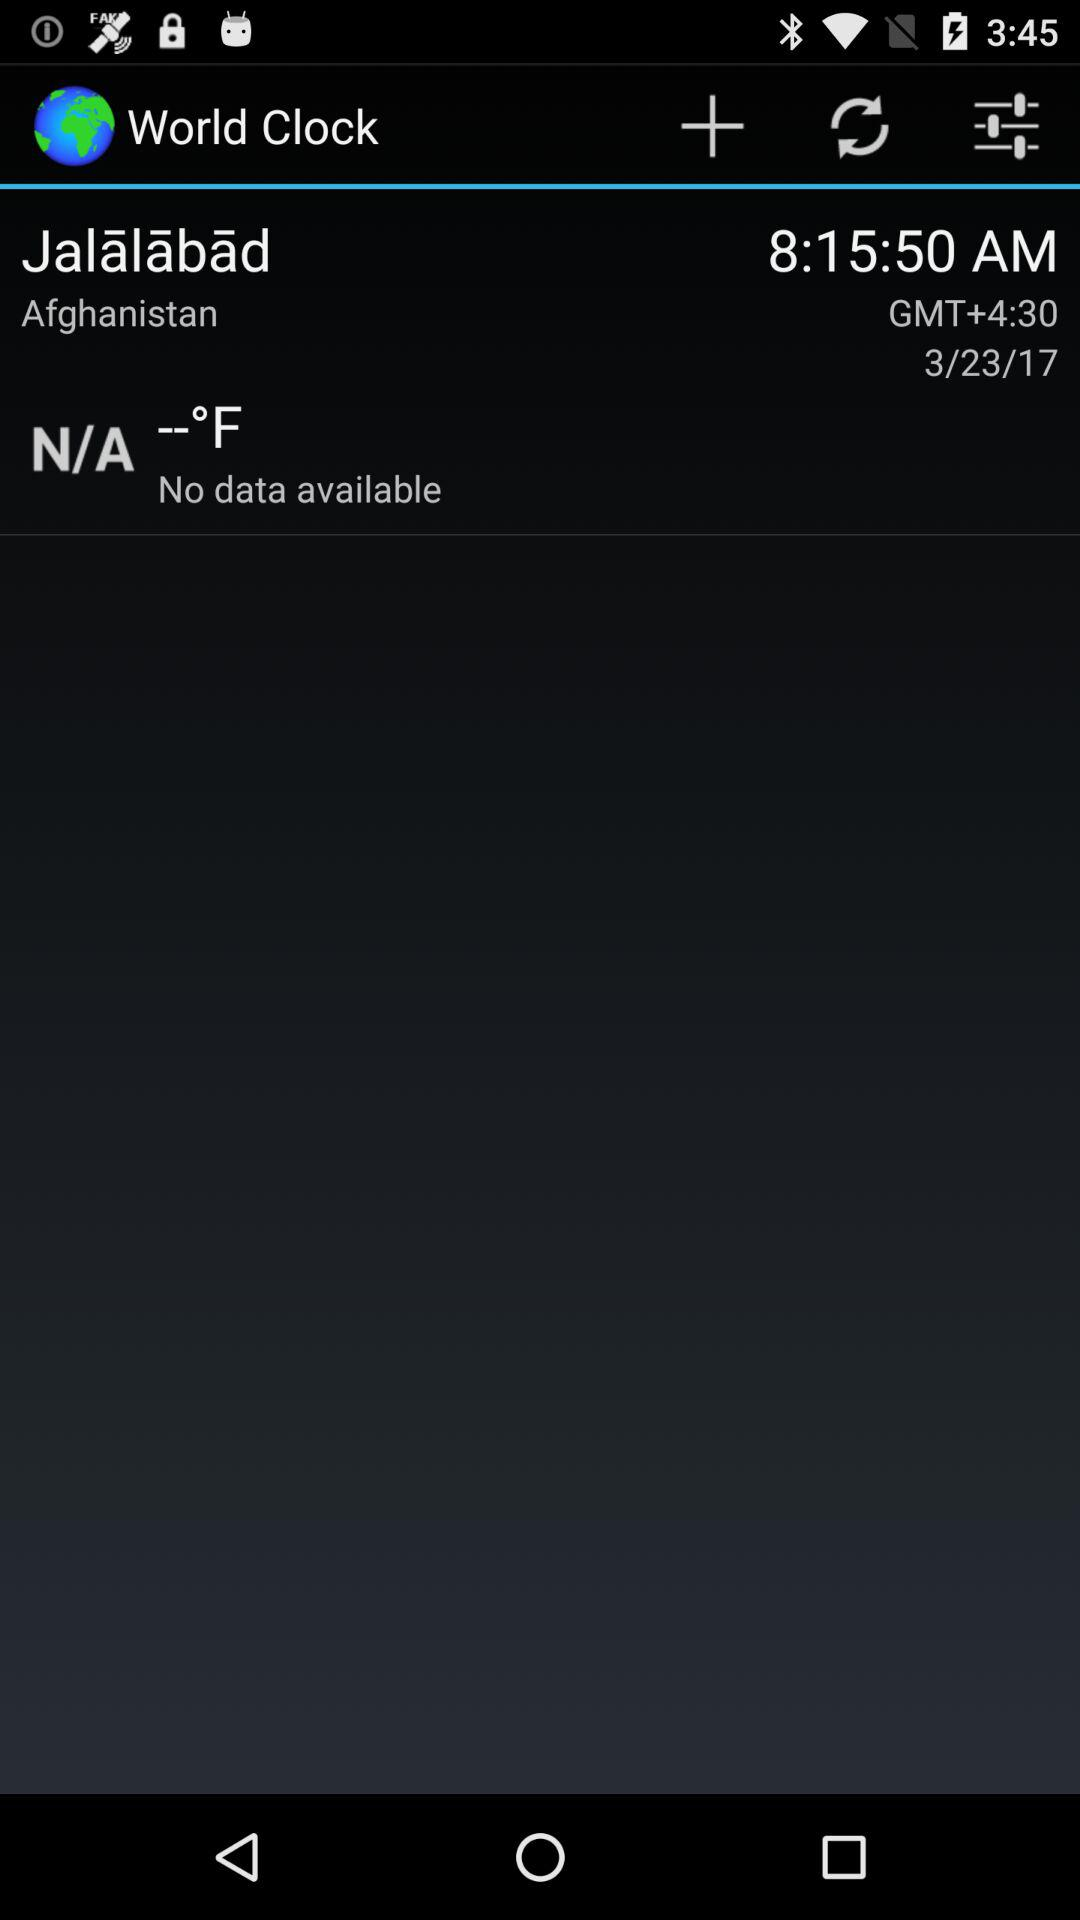What is the time in Jalalabad? The time is 8:15:50 AM. 